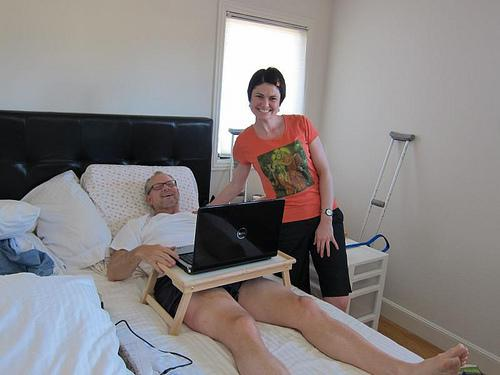Question: what color is the woman's shirt?
Choices:
A. Black.
B. Orange.
C. White.
D. Gray.
Answer with the letter. Answer: B Question: what is on the tray?
Choices:
A. Food.
B. Laptop.
C. Books.
D. Papers.
Answer with the letter. Answer: B Question: how many people in the room?
Choices:
A. Thirty.
B. Two.
C. Forty.
D. Thirteen.
Answer with the letter. Answer: B Question: what is the man holding?
Choices:
A. Food.
B. Drink.
C. Phone.
D. Tray.
Answer with the letter. Answer: D 